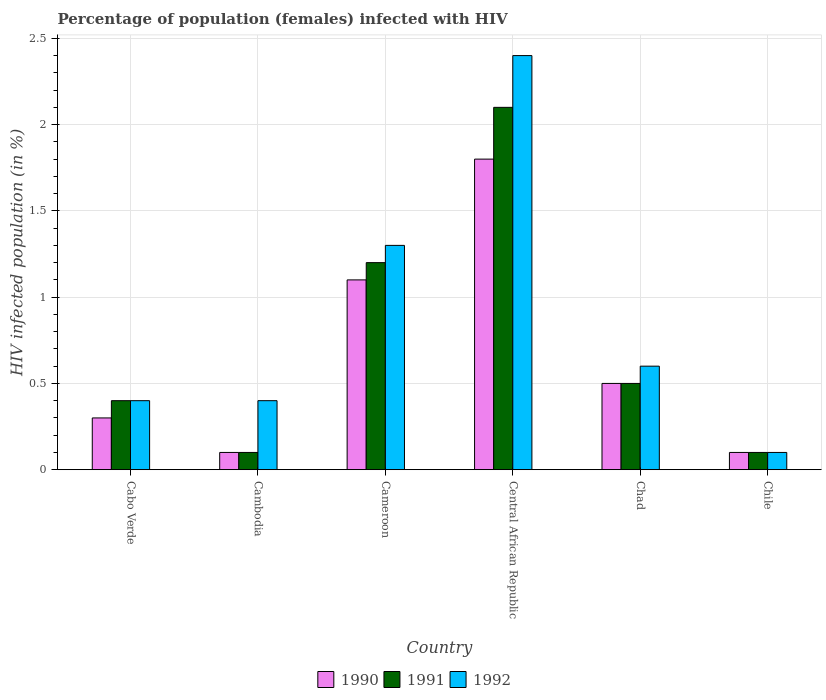Are the number of bars per tick equal to the number of legend labels?
Your response must be concise. Yes. How many bars are there on the 2nd tick from the right?
Keep it short and to the point. 3. What is the label of the 1st group of bars from the left?
Make the answer very short. Cabo Verde. In how many cases, is the number of bars for a given country not equal to the number of legend labels?
Provide a short and direct response. 0. What is the percentage of HIV infected female population in 1992 in Cameroon?
Give a very brief answer. 1.3. Across all countries, what is the minimum percentage of HIV infected female population in 1991?
Provide a short and direct response. 0.1. In which country was the percentage of HIV infected female population in 1991 maximum?
Your response must be concise. Central African Republic. In which country was the percentage of HIV infected female population in 1991 minimum?
Give a very brief answer. Cambodia. What is the total percentage of HIV infected female population in 1991 in the graph?
Keep it short and to the point. 4.4. What is the difference between the percentage of HIV infected female population in 1991 in Cambodia and that in Chile?
Your answer should be compact. 0. What is the difference between the percentage of HIV infected female population in 1992 in Cabo Verde and the percentage of HIV infected female population in 1991 in Cambodia?
Keep it short and to the point. 0.3. What is the average percentage of HIV infected female population in 1992 per country?
Offer a very short reply. 0.87. What is the difference between the percentage of HIV infected female population of/in 1992 and percentage of HIV infected female population of/in 1990 in Chile?
Keep it short and to the point. 0. What is the ratio of the percentage of HIV infected female population in 1990 in Cabo Verde to that in Chad?
Make the answer very short. 0.6. Is the percentage of HIV infected female population in 1992 in Cameroon less than that in Central African Republic?
Make the answer very short. Yes. Is the difference between the percentage of HIV infected female population in 1992 in Cabo Verde and Central African Republic greater than the difference between the percentage of HIV infected female population in 1990 in Cabo Verde and Central African Republic?
Offer a very short reply. No. What is the difference between the highest and the lowest percentage of HIV infected female population in 1992?
Ensure brevity in your answer.  2.3. Is the sum of the percentage of HIV infected female population in 1991 in Cambodia and Chad greater than the maximum percentage of HIV infected female population in 1990 across all countries?
Ensure brevity in your answer.  No. What does the 1st bar from the right in Cabo Verde represents?
Keep it short and to the point. 1992. Are all the bars in the graph horizontal?
Provide a succinct answer. No. What is the difference between two consecutive major ticks on the Y-axis?
Offer a very short reply. 0.5. Are the values on the major ticks of Y-axis written in scientific E-notation?
Provide a succinct answer. No. Does the graph contain any zero values?
Offer a very short reply. No. How many legend labels are there?
Offer a terse response. 3. What is the title of the graph?
Give a very brief answer. Percentage of population (females) infected with HIV. Does "2005" appear as one of the legend labels in the graph?
Keep it short and to the point. No. What is the label or title of the X-axis?
Your answer should be very brief. Country. What is the label or title of the Y-axis?
Provide a short and direct response. HIV infected population (in %). What is the HIV infected population (in %) in 1992 in Cabo Verde?
Your response must be concise. 0.4. What is the HIV infected population (in %) of 1991 in Cambodia?
Ensure brevity in your answer.  0.1. What is the HIV infected population (in %) of 1990 in Cameroon?
Your answer should be very brief. 1.1. What is the HIV infected population (in %) of 1991 in Cameroon?
Your answer should be very brief. 1.2. What is the HIV infected population (in %) in 1992 in Cameroon?
Keep it short and to the point. 1.3. What is the HIV infected population (in %) of 1991 in Central African Republic?
Ensure brevity in your answer.  2.1. What is the HIV infected population (in %) of 1992 in Central African Republic?
Keep it short and to the point. 2.4. What is the HIV infected population (in %) in 1990 in Chad?
Provide a succinct answer. 0.5. What is the HIV infected population (in %) of 1990 in Chile?
Make the answer very short. 0.1. Across all countries, what is the maximum HIV infected population (in %) in 1992?
Your answer should be compact. 2.4. Across all countries, what is the minimum HIV infected population (in %) of 1991?
Provide a short and direct response. 0.1. Across all countries, what is the minimum HIV infected population (in %) of 1992?
Keep it short and to the point. 0.1. What is the total HIV infected population (in %) of 1990 in the graph?
Your answer should be compact. 3.9. What is the total HIV infected population (in %) of 1991 in the graph?
Provide a succinct answer. 4.4. What is the difference between the HIV infected population (in %) in 1990 in Cabo Verde and that in Cambodia?
Keep it short and to the point. 0.2. What is the difference between the HIV infected population (in %) of 1991 in Cabo Verde and that in Cambodia?
Your answer should be compact. 0.3. What is the difference between the HIV infected population (in %) of 1990 in Cabo Verde and that in Cameroon?
Make the answer very short. -0.8. What is the difference between the HIV infected population (in %) of 1990 in Cabo Verde and that in Central African Republic?
Provide a short and direct response. -1.5. What is the difference between the HIV infected population (in %) of 1991 in Cabo Verde and that in Central African Republic?
Offer a terse response. -1.7. What is the difference between the HIV infected population (in %) of 1992 in Cabo Verde and that in Central African Republic?
Give a very brief answer. -2. What is the difference between the HIV infected population (in %) of 1990 in Cabo Verde and that in Chile?
Your answer should be very brief. 0.2. What is the difference between the HIV infected population (in %) of 1990 in Cambodia and that in Cameroon?
Keep it short and to the point. -1. What is the difference between the HIV infected population (in %) in 1991 in Cambodia and that in Cameroon?
Your answer should be very brief. -1.1. What is the difference between the HIV infected population (in %) of 1990 in Cambodia and that in Central African Republic?
Provide a short and direct response. -1.7. What is the difference between the HIV infected population (in %) of 1991 in Cambodia and that in Central African Republic?
Offer a very short reply. -2. What is the difference between the HIV infected population (in %) of 1992 in Cambodia and that in Central African Republic?
Offer a very short reply. -2. What is the difference between the HIV infected population (in %) of 1991 in Cameroon and that in Central African Republic?
Provide a succinct answer. -0.9. What is the difference between the HIV infected population (in %) of 1990 in Cameroon and that in Chad?
Offer a terse response. 0.6. What is the difference between the HIV infected population (in %) of 1992 in Cameroon and that in Chad?
Your answer should be very brief. 0.7. What is the difference between the HIV infected population (in %) in 1991 in Cameroon and that in Chile?
Offer a terse response. 1.1. What is the difference between the HIV infected population (in %) of 1992 in Central African Republic and that in Chad?
Your answer should be very brief. 1.8. What is the difference between the HIV infected population (in %) of 1991 in Central African Republic and that in Chile?
Offer a terse response. 2. What is the difference between the HIV infected population (in %) in 1990 in Chad and that in Chile?
Offer a very short reply. 0.4. What is the difference between the HIV infected population (in %) in 1990 in Cabo Verde and the HIV infected population (in %) in 1992 in Cambodia?
Offer a terse response. -0.1. What is the difference between the HIV infected population (in %) in 1991 in Cabo Verde and the HIV infected population (in %) in 1992 in Cameroon?
Provide a succinct answer. -0.9. What is the difference between the HIV infected population (in %) of 1990 in Cabo Verde and the HIV infected population (in %) of 1991 in Central African Republic?
Give a very brief answer. -1.8. What is the difference between the HIV infected population (in %) of 1991 in Cabo Verde and the HIV infected population (in %) of 1992 in Central African Republic?
Make the answer very short. -2. What is the difference between the HIV infected population (in %) of 1990 in Cabo Verde and the HIV infected population (in %) of 1991 in Chad?
Keep it short and to the point. -0.2. What is the difference between the HIV infected population (in %) in 1990 in Cabo Verde and the HIV infected population (in %) in 1992 in Chad?
Your answer should be compact. -0.3. What is the difference between the HIV infected population (in %) of 1990 in Cabo Verde and the HIV infected population (in %) of 1991 in Chile?
Give a very brief answer. 0.2. What is the difference between the HIV infected population (in %) of 1990 in Cabo Verde and the HIV infected population (in %) of 1992 in Chile?
Your answer should be compact. 0.2. What is the difference between the HIV infected population (in %) of 1991 in Cabo Verde and the HIV infected population (in %) of 1992 in Chile?
Provide a short and direct response. 0.3. What is the difference between the HIV infected population (in %) in 1990 in Cambodia and the HIV infected population (in %) in 1991 in Cameroon?
Make the answer very short. -1.1. What is the difference between the HIV infected population (in %) in 1990 in Cambodia and the HIV infected population (in %) in 1992 in Chile?
Ensure brevity in your answer.  0. What is the difference between the HIV infected population (in %) in 1991 in Cambodia and the HIV infected population (in %) in 1992 in Chile?
Keep it short and to the point. 0. What is the difference between the HIV infected population (in %) in 1990 in Cameroon and the HIV infected population (in %) in 1991 in Central African Republic?
Give a very brief answer. -1. What is the difference between the HIV infected population (in %) of 1990 in Cameroon and the HIV infected population (in %) of 1991 in Chad?
Give a very brief answer. 0.6. What is the difference between the HIV infected population (in %) in 1990 in Central African Republic and the HIV infected population (in %) in 1992 in Chad?
Give a very brief answer. 1.2. What is the difference between the HIV infected population (in %) of 1991 in Central African Republic and the HIV infected population (in %) of 1992 in Chad?
Give a very brief answer. 1.5. What is the difference between the HIV infected population (in %) of 1990 in Central African Republic and the HIV infected population (in %) of 1991 in Chile?
Your response must be concise. 1.7. What is the difference between the HIV infected population (in %) of 1990 in Central African Republic and the HIV infected population (in %) of 1992 in Chile?
Your answer should be very brief. 1.7. What is the difference between the HIV infected population (in %) of 1991 in Central African Republic and the HIV infected population (in %) of 1992 in Chile?
Your answer should be compact. 2. What is the difference between the HIV infected population (in %) of 1990 in Chad and the HIV infected population (in %) of 1992 in Chile?
Make the answer very short. 0.4. What is the average HIV infected population (in %) in 1990 per country?
Offer a terse response. 0.65. What is the average HIV infected population (in %) of 1991 per country?
Offer a terse response. 0.73. What is the average HIV infected population (in %) in 1992 per country?
Keep it short and to the point. 0.87. What is the difference between the HIV infected population (in %) of 1990 and HIV infected population (in %) of 1991 in Cabo Verde?
Offer a very short reply. -0.1. What is the difference between the HIV infected population (in %) in 1991 and HIV infected population (in %) in 1992 in Cabo Verde?
Provide a succinct answer. 0. What is the difference between the HIV infected population (in %) in 1990 and HIV infected population (in %) in 1991 in Cameroon?
Your answer should be very brief. -0.1. What is the difference between the HIV infected population (in %) in 1991 and HIV infected population (in %) in 1992 in Cameroon?
Your response must be concise. -0.1. What is the difference between the HIV infected population (in %) in 1991 and HIV infected population (in %) in 1992 in Chad?
Offer a very short reply. -0.1. What is the difference between the HIV infected population (in %) in 1990 and HIV infected population (in %) in 1992 in Chile?
Offer a terse response. 0. What is the difference between the HIV infected population (in %) in 1991 and HIV infected population (in %) in 1992 in Chile?
Give a very brief answer. 0. What is the ratio of the HIV infected population (in %) of 1990 in Cabo Verde to that in Cambodia?
Provide a succinct answer. 3. What is the ratio of the HIV infected population (in %) in 1991 in Cabo Verde to that in Cambodia?
Offer a very short reply. 4. What is the ratio of the HIV infected population (in %) in 1990 in Cabo Verde to that in Cameroon?
Ensure brevity in your answer.  0.27. What is the ratio of the HIV infected population (in %) of 1992 in Cabo Verde to that in Cameroon?
Offer a very short reply. 0.31. What is the ratio of the HIV infected population (in %) of 1990 in Cabo Verde to that in Central African Republic?
Offer a very short reply. 0.17. What is the ratio of the HIV infected population (in %) of 1991 in Cabo Verde to that in Central African Republic?
Keep it short and to the point. 0.19. What is the ratio of the HIV infected population (in %) of 1991 in Cabo Verde to that in Chad?
Your answer should be compact. 0.8. What is the ratio of the HIV infected population (in %) in 1992 in Cabo Verde to that in Chad?
Your response must be concise. 0.67. What is the ratio of the HIV infected population (in %) of 1991 in Cabo Verde to that in Chile?
Offer a very short reply. 4. What is the ratio of the HIV infected population (in %) of 1990 in Cambodia to that in Cameroon?
Make the answer very short. 0.09. What is the ratio of the HIV infected population (in %) of 1991 in Cambodia to that in Cameroon?
Provide a short and direct response. 0.08. What is the ratio of the HIV infected population (in %) in 1992 in Cambodia to that in Cameroon?
Your answer should be very brief. 0.31. What is the ratio of the HIV infected population (in %) of 1990 in Cambodia to that in Central African Republic?
Make the answer very short. 0.06. What is the ratio of the HIV infected population (in %) in 1991 in Cambodia to that in Central African Republic?
Make the answer very short. 0.05. What is the ratio of the HIV infected population (in %) of 1991 in Cambodia to that in Chad?
Offer a very short reply. 0.2. What is the ratio of the HIV infected population (in %) in 1992 in Cambodia to that in Chad?
Your response must be concise. 0.67. What is the ratio of the HIV infected population (in %) in 1990 in Cambodia to that in Chile?
Ensure brevity in your answer.  1. What is the ratio of the HIV infected population (in %) in 1991 in Cambodia to that in Chile?
Your answer should be very brief. 1. What is the ratio of the HIV infected population (in %) in 1990 in Cameroon to that in Central African Republic?
Provide a short and direct response. 0.61. What is the ratio of the HIV infected population (in %) in 1992 in Cameroon to that in Central African Republic?
Offer a very short reply. 0.54. What is the ratio of the HIV infected population (in %) in 1990 in Cameroon to that in Chad?
Keep it short and to the point. 2.2. What is the ratio of the HIV infected population (in %) in 1992 in Cameroon to that in Chad?
Keep it short and to the point. 2.17. What is the ratio of the HIV infected population (in %) of 1992 in Cameroon to that in Chile?
Offer a terse response. 13. What is the ratio of the HIV infected population (in %) in 1990 in Central African Republic to that in Chad?
Keep it short and to the point. 3.6. What is the ratio of the HIV infected population (in %) in 1992 in Central African Republic to that in Chad?
Make the answer very short. 4. What is the ratio of the HIV infected population (in %) of 1990 in Chad to that in Chile?
Provide a succinct answer. 5. What is the ratio of the HIV infected population (in %) in 1991 in Chad to that in Chile?
Your response must be concise. 5. What is the ratio of the HIV infected population (in %) of 1992 in Chad to that in Chile?
Your answer should be very brief. 6. What is the difference between the highest and the second highest HIV infected population (in %) of 1990?
Ensure brevity in your answer.  0.7. What is the difference between the highest and the lowest HIV infected population (in %) of 1990?
Ensure brevity in your answer.  1.7. What is the difference between the highest and the lowest HIV infected population (in %) of 1991?
Your answer should be very brief. 2. 